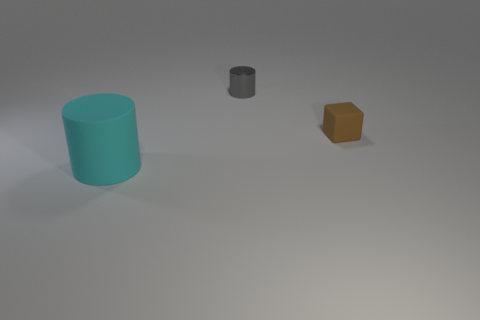What material is the big cylinder on the left side of the rubber object that is right of the matte thing that is in front of the small brown matte thing made of?
Keep it short and to the point. Rubber. There is a thing that is made of the same material as the block; what is its size?
Your answer should be compact. Large. The tiny thing that is on the right side of the cylinder behind the brown block is what color?
Provide a short and direct response. Brown. What number of large cyan things are made of the same material as the cube?
Keep it short and to the point. 1. How many matte objects are small gray objects or green cylinders?
Your answer should be compact. 0. What is the material of the other object that is the same size as the gray thing?
Ensure brevity in your answer.  Rubber. Is there a tiny red sphere that has the same material as the tiny brown object?
Your answer should be compact. No. The rubber object right of the matte thing in front of the thing to the right of the small cylinder is what shape?
Your answer should be very brief. Cube. Does the cyan object have the same size as the cylinder behind the cyan thing?
Provide a succinct answer. No. What shape is the thing that is in front of the metal cylinder and right of the big object?
Your answer should be compact. Cube. 